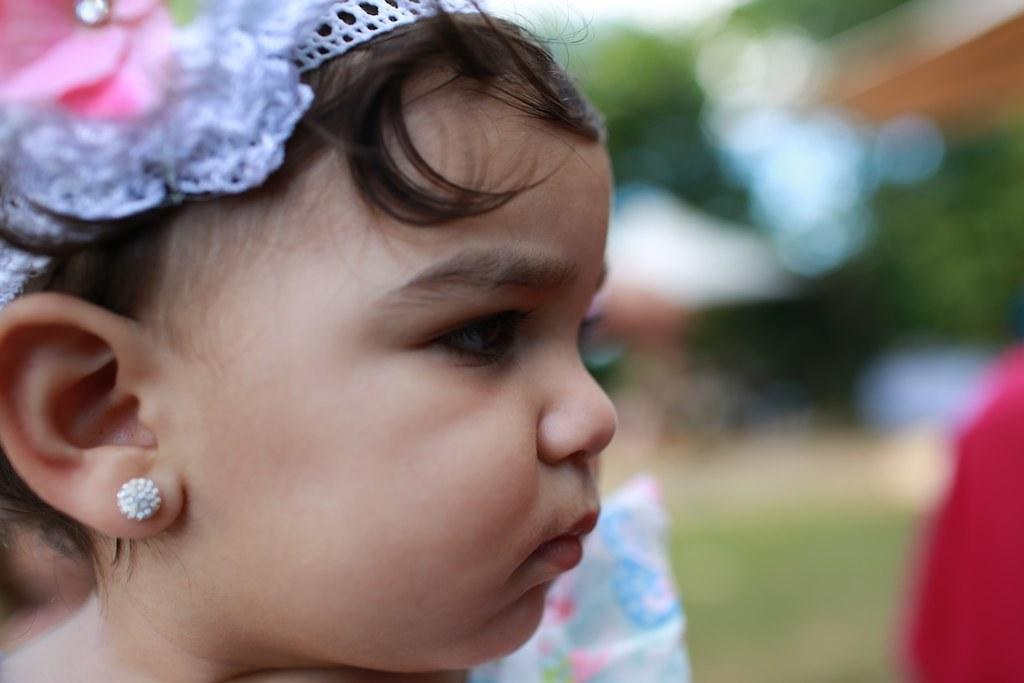What is the main subject of the image? There is a person in the image. Can you describe any specific accessory the person is wearing? The person is wearing a white hair band. What can be observed about the background of the image? The background of the image is blurred. How many snakes are visible in the image? There are no snakes present in the image. What is the amount of dirt the person is raking in the image? There is no rake or dirt visible in the image. 